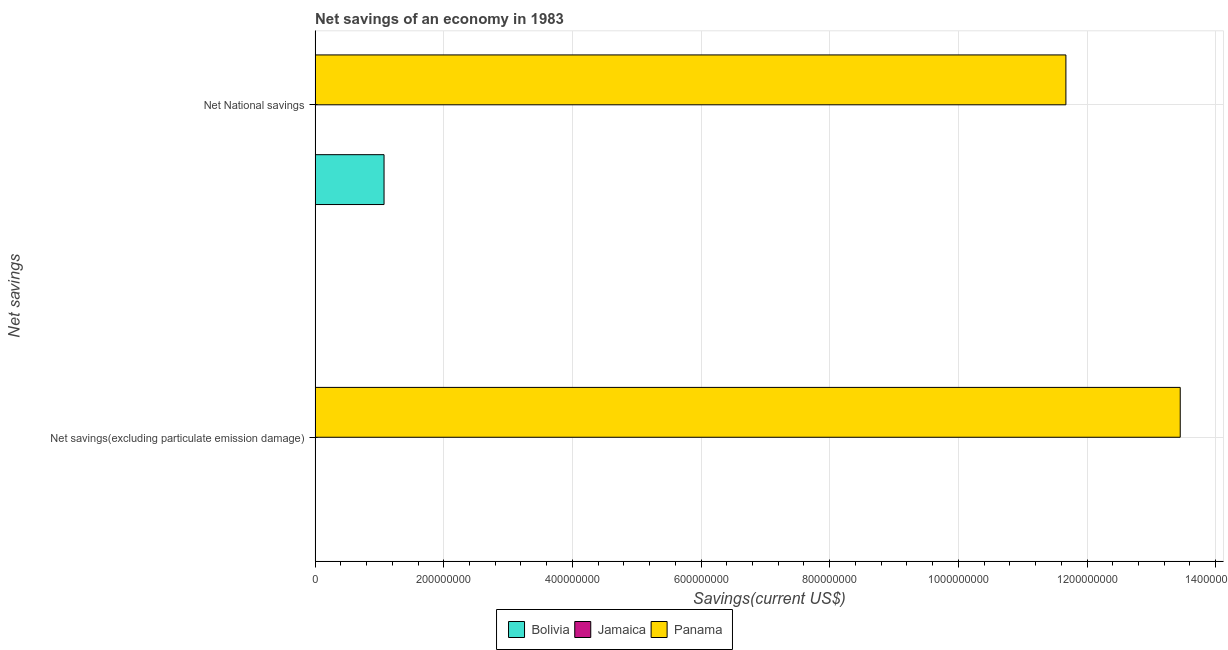How many different coloured bars are there?
Provide a succinct answer. 2. Are the number of bars per tick equal to the number of legend labels?
Your answer should be very brief. No. How many bars are there on the 1st tick from the bottom?
Your response must be concise. 1. What is the label of the 2nd group of bars from the top?
Offer a terse response. Net savings(excluding particulate emission damage). What is the net national savings in Bolivia?
Ensure brevity in your answer.  1.07e+08. Across all countries, what is the maximum net savings(excluding particulate emission damage)?
Keep it short and to the point. 1.34e+09. Across all countries, what is the minimum net national savings?
Make the answer very short. 0. In which country was the net national savings maximum?
Ensure brevity in your answer.  Panama. What is the total net national savings in the graph?
Offer a terse response. 1.27e+09. What is the difference between the net national savings in Bolivia and that in Panama?
Your answer should be very brief. -1.06e+09. What is the difference between the net national savings in Panama and the net savings(excluding particulate emission damage) in Jamaica?
Give a very brief answer. 1.17e+09. What is the average net national savings per country?
Ensure brevity in your answer.  4.25e+08. What is the difference between the net savings(excluding particulate emission damage) and net national savings in Panama?
Offer a terse response. 1.78e+08. In how many countries, is the net national savings greater than 1160000000 US$?
Your answer should be very brief. 1. Is the net national savings in Bolivia less than that in Panama?
Your answer should be very brief. Yes. In how many countries, is the net savings(excluding particulate emission damage) greater than the average net savings(excluding particulate emission damage) taken over all countries?
Offer a very short reply. 1. How many bars are there?
Your answer should be compact. 3. Are all the bars in the graph horizontal?
Give a very brief answer. Yes. Are the values on the major ticks of X-axis written in scientific E-notation?
Ensure brevity in your answer.  No. Does the graph contain any zero values?
Keep it short and to the point. Yes. Does the graph contain grids?
Provide a short and direct response. Yes. How are the legend labels stacked?
Ensure brevity in your answer.  Horizontal. What is the title of the graph?
Your response must be concise. Net savings of an economy in 1983. Does "Myanmar" appear as one of the legend labels in the graph?
Your answer should be very brief. No. What is the label or title of the X-axis?
Provide a short and direct response. Savings(current US$). What is the label or title of the Y-axis?
Keep it short and to the point. Net savings. What is the Savings(current US$) of Bolivia in Net savings(excluding particulate emission damage)?
Provide a short and direct response. 0. What is the Savings(current US$) of Panama in Net savings(excluding particulate emission damage)?
Make the answer very short. 1.34e+09. What is the Savings(current US$) of Bolivia in Net National savings?
Ensure brevity in your answer.  1.07e+08. What is the Savings(current US$) in Jamaica in Net National savings?
Provide a short and direct response. 0. What is the Savings(current US$) of Panama in Net National savings?
Give a very brief answer. 1.17e+09. Across all Net savings, what is the maximum Savings(current US$) in Bolivia?
Ensure brevity in your answer.  1.07e+08. Across all Net savings, what is the maximum Savings(current US$) in Panama?
Your answer should be very brief. 1.34e+09. Across all Net savings, what is the minimum Savings(current US$) of Bolivia?
Offer a terse response. 0. Across all Net savings, what is the minimum Savings(current US$) of Panama?
Your answer should be very brief. 1.17e+09. What is the total Savings(current US$) of Bolivia in the graph?
Offer a very short reply. 1.07e+08. What is the total Savings(current US$) of Jamaica in the graph?
Your answer should be very brief. 0. What is the total Savings(current US$) of Panama in the graph?
Provide a succinct answer. 2.51e+09. What is the difference between the Savings(current US$) of Panama in Net savings(excluding particulate emission damage) and that in Net National savings?
Give a very brief answer. 1.78e+08. What is the average Savings(current US$) in Bolivia per Net savings?
Make the answer very short. 5.36e+07. What is the average Savings(current US$) in Jamaica per Net savings?
Offer a very short reply. 0. What is the average Savings(current US$) in Panama per Net savings?
Provide a short and direct response. 1.26e+09. What is the difference between the Savings(current US$) of Bolivia and Savings(current US$) of Panama in Net National savings?
Make the answer very short. -1.06e+09. What is the ratio of the Savings(current US$) in Panama in Net savings(excluding particulate emission damage) to that in Net National savings?
Provide a short and direct response. 1.15. What is the difference between the highest and the second highest Savings(current US$) of Panama?
Provide a succinct answer. 1.78e+08. What is the difference between the highest and the lowest Savings(current US$) in Bolivia?
Make the answer very short. 1.07e+08. What is the difference between the highest and the lowest Savings(current US$) of Panama?
Provide a short and direct response. 1.78e+08. 